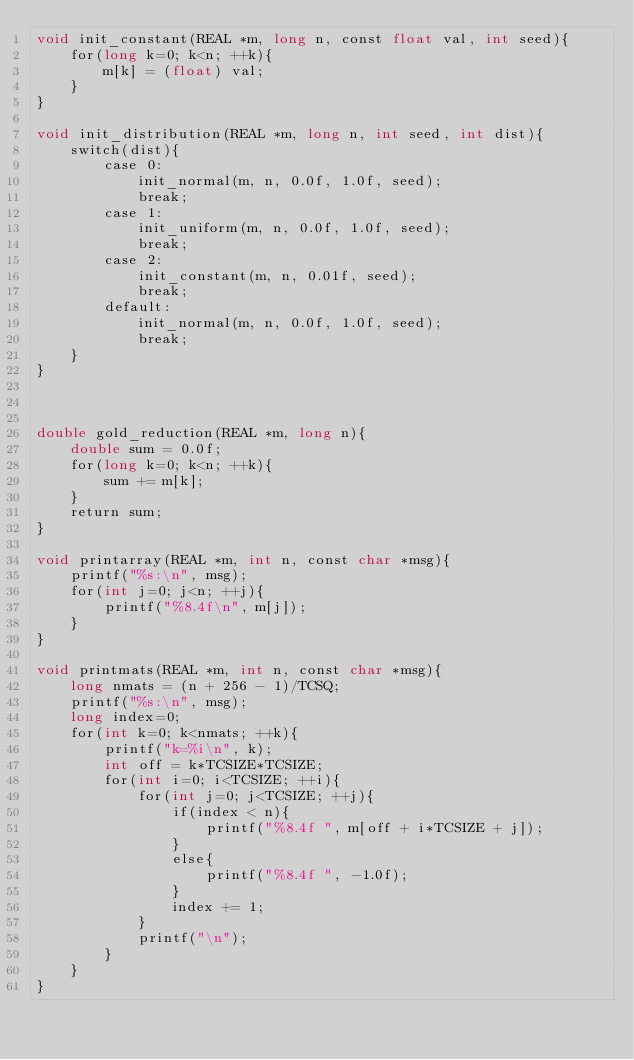<code> <loc_0><loc_0><loc_500><loc_500><_Cuda_>void init_constant(REAL *m, long n, const float val, int seed){
    for(long k=0; k<n; ++k){
        m[k] = (float) val;
    }
}

void init_distribution(REAL *m, long n, int seed, int dist){
    switch(dist){
        case 0: 
            init_normal(m, n, 0.0f, 1.0f, seed);
            break;
        case 1:
            init_uniform(m, n, 0.0f, 1.0f, seed);
            break;
        case 2:
            init_constant(m, n, 0.01f, seed);
            break;
        default:
            init_normal(m, n, 0.0f, 1.0f, seed);
            break;
    }
}



double gold_reduction(REAL *m, long n){
    double sum = 0.0f;
    for(long k=0; k<n; ++k){
        sum += m[k];
    }
    return sum;
}

void printarray(REAL *m, int n, const char *msg){
    printf("%s:\n", msg);
    for(int j=0; j<n; ++j){
        printf("%8.4f\n", m[j]);
    }
}

void printmats(REAL *m, int n, const char *msg){
    long nmats = (n + 256 - 1)/TCSQ;
    printf("%s:\n", msg);
    long index=0;
    for(int k=0; k<nmats; ++k){
        printf("k=%i\n", k);
        int off = k*TCSIZE*TCSIZE;
        for(int i=0; i<TCSIZE; ++i){
            for(int j=0; j<TCSIZE; ++j){
                if(index < n){
                    printf("%8.4f ", m[off + i*TCSIZE + j]);
                }
                else{
                    printf("%8.4f ", -1.0f);
                }
                index += 1;
            }
            printf("\n");
        }
    }
}

</code> 